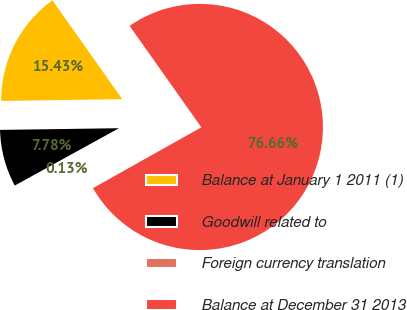Convert chart to OTSL. <chart><loc_0><loc_0><loc_500><loc_500><pie_chart><fcel>Balance at January 1 2011 (1)<fcel>Goodwill related to<fcel>Foreign currency translation<fcel>Balance at December 31 2013<nl><fcel>15.43%<fcel>7.78%<fcel>0.13%<fcel>76.65%<nl></chart> 